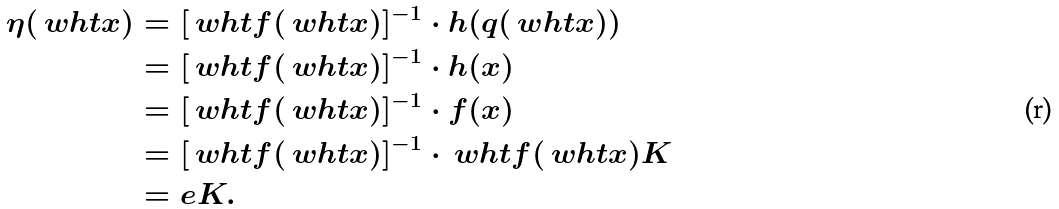Convert formula to latex. <formula><loc_0><loc_0><loc_500><loc_500>\eta ( \ w h t x ) & = [ \ w h t { f } ( \ w h t x ) ] ^ { - 1 } \cdot h ( q ( \ w h t x ) ) \\ & = [ \ w h t { f } ( \ w h t x ) ] ^ { - 1 } \cdot h ( x ) \\ & = [ \ w h t { f } ( \ w h t x ) ] ^ { - 1 } \cdot f ( x ) \\ & = [ \ w h t { f } ( \ w h t x ) ] ^ { - 1 } \cdot \ w h t { f } ( \ w h t x ) K \\ & = e K .</formula> 